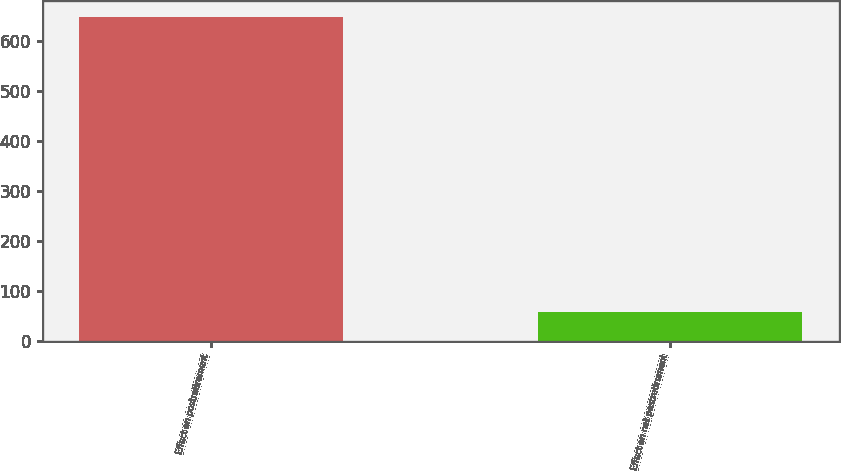<chart> <loc_0><loc_0><loc_500><loc_500><bar_chart><fcel>Effect on postretirement<fcel>Effect on net postretirement<nl><fcel>647<fcel>59<nl></chart> 